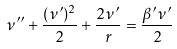Convert formula to latex. <formula><loc_0><loc_0><loc_500><loc_500>\nu ^ { \prime \prime } + \frac { ( \nu ^ { \prime } ) ^ { 2 } } { 2 } + \frac { 2 \nu ^ { \prime } } { r } = \frac { \beta ^ { \prime } \nu ^ { \prime } } { 2 }</formula> 